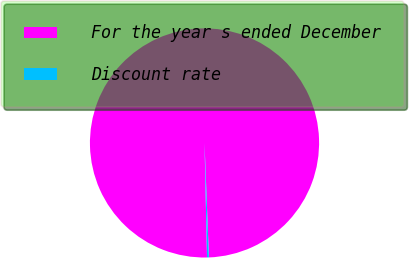<chart> <loc_0><loc_0><loc_500><loc_500><pie_chart><fcel>For the year s ended December<fcel>Discount rate<nl><fcel>99.74%<fcel>0.26%<nl></chart> 